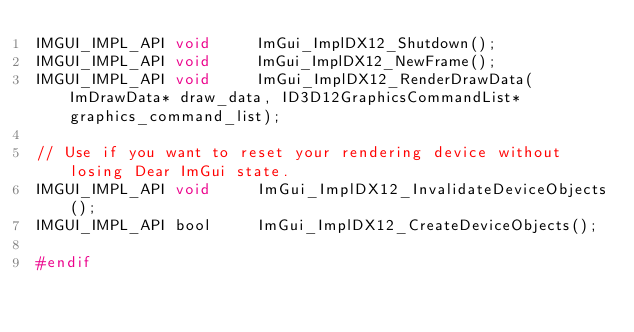Convert code to text. <code><loc_0><loc_0><loc_500><loc_500><_C_>IMGUI_IMPL_API void     ImGui_ImplDX12_Shutdown();
IMGUI_IMPL_API void     ImGui_ImplDX12_NewFrame();
IMGUI_IMPL_API void     ImGui_ImplDX12_RenderDrawData(ImDrawData* draw_data, ID3D12GraphicsCommandList* graphics_command_list);

// Use if you want to reset your rendering device without losing Dear ImGui state.
IMGUI_IMPL_API void     ImGui_ImplDX12_InvalidateDeviceObjects();
IMGUI_IMPL_API bool     ImGui_ImplDX12_CreateDeviceObjects();

#endif
</code> 